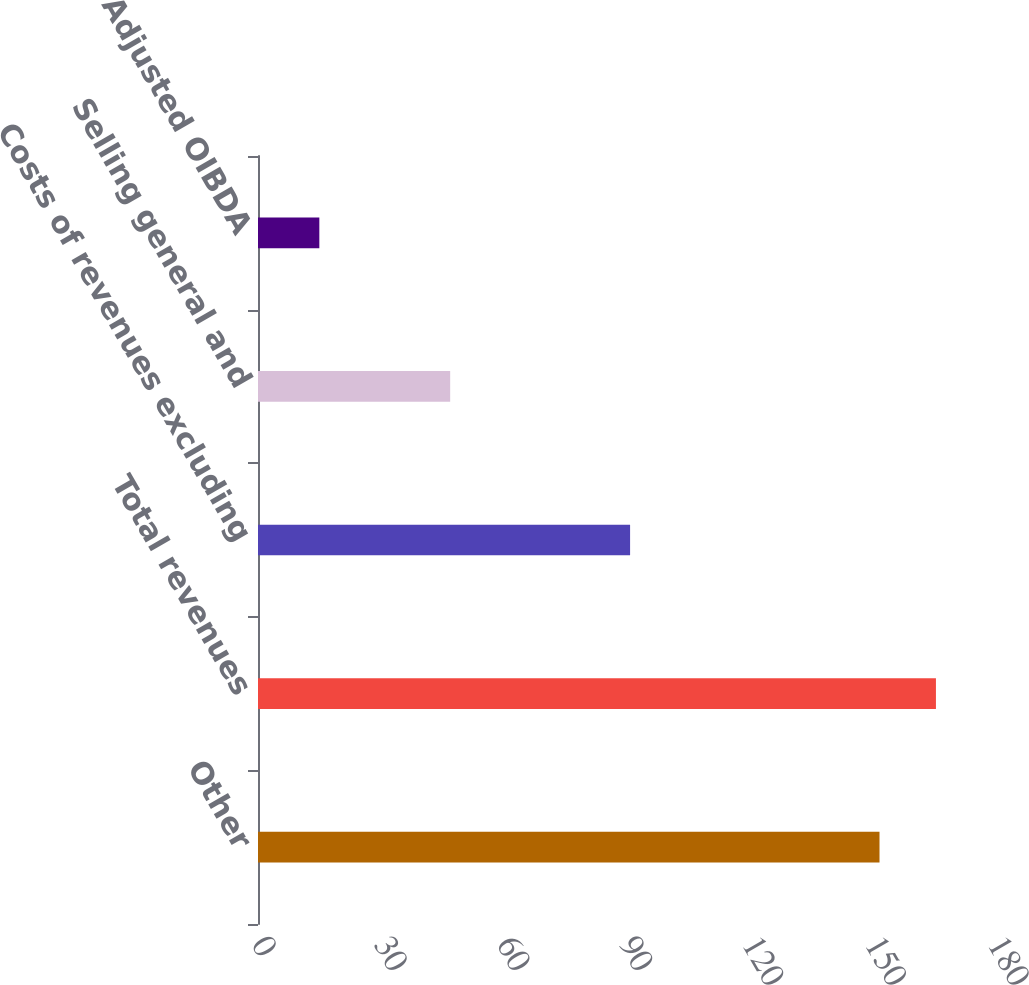Convert chart to OTSL. <chart><loc_0><loc_0><loc_500><loc_500><bar_chart><fcel>Other<fcel>Total revenues<fcel>Costs of revenues excluding<fcel>Selling general and<fcel>Adjusted OIBDA<nl><fcel>152<fcel>165.8<fcel>91<fcel>47<fcel>15<nl></chart> 